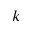<formula> <loc_0><loc_0><loc_500><loc_500>k</formula> 